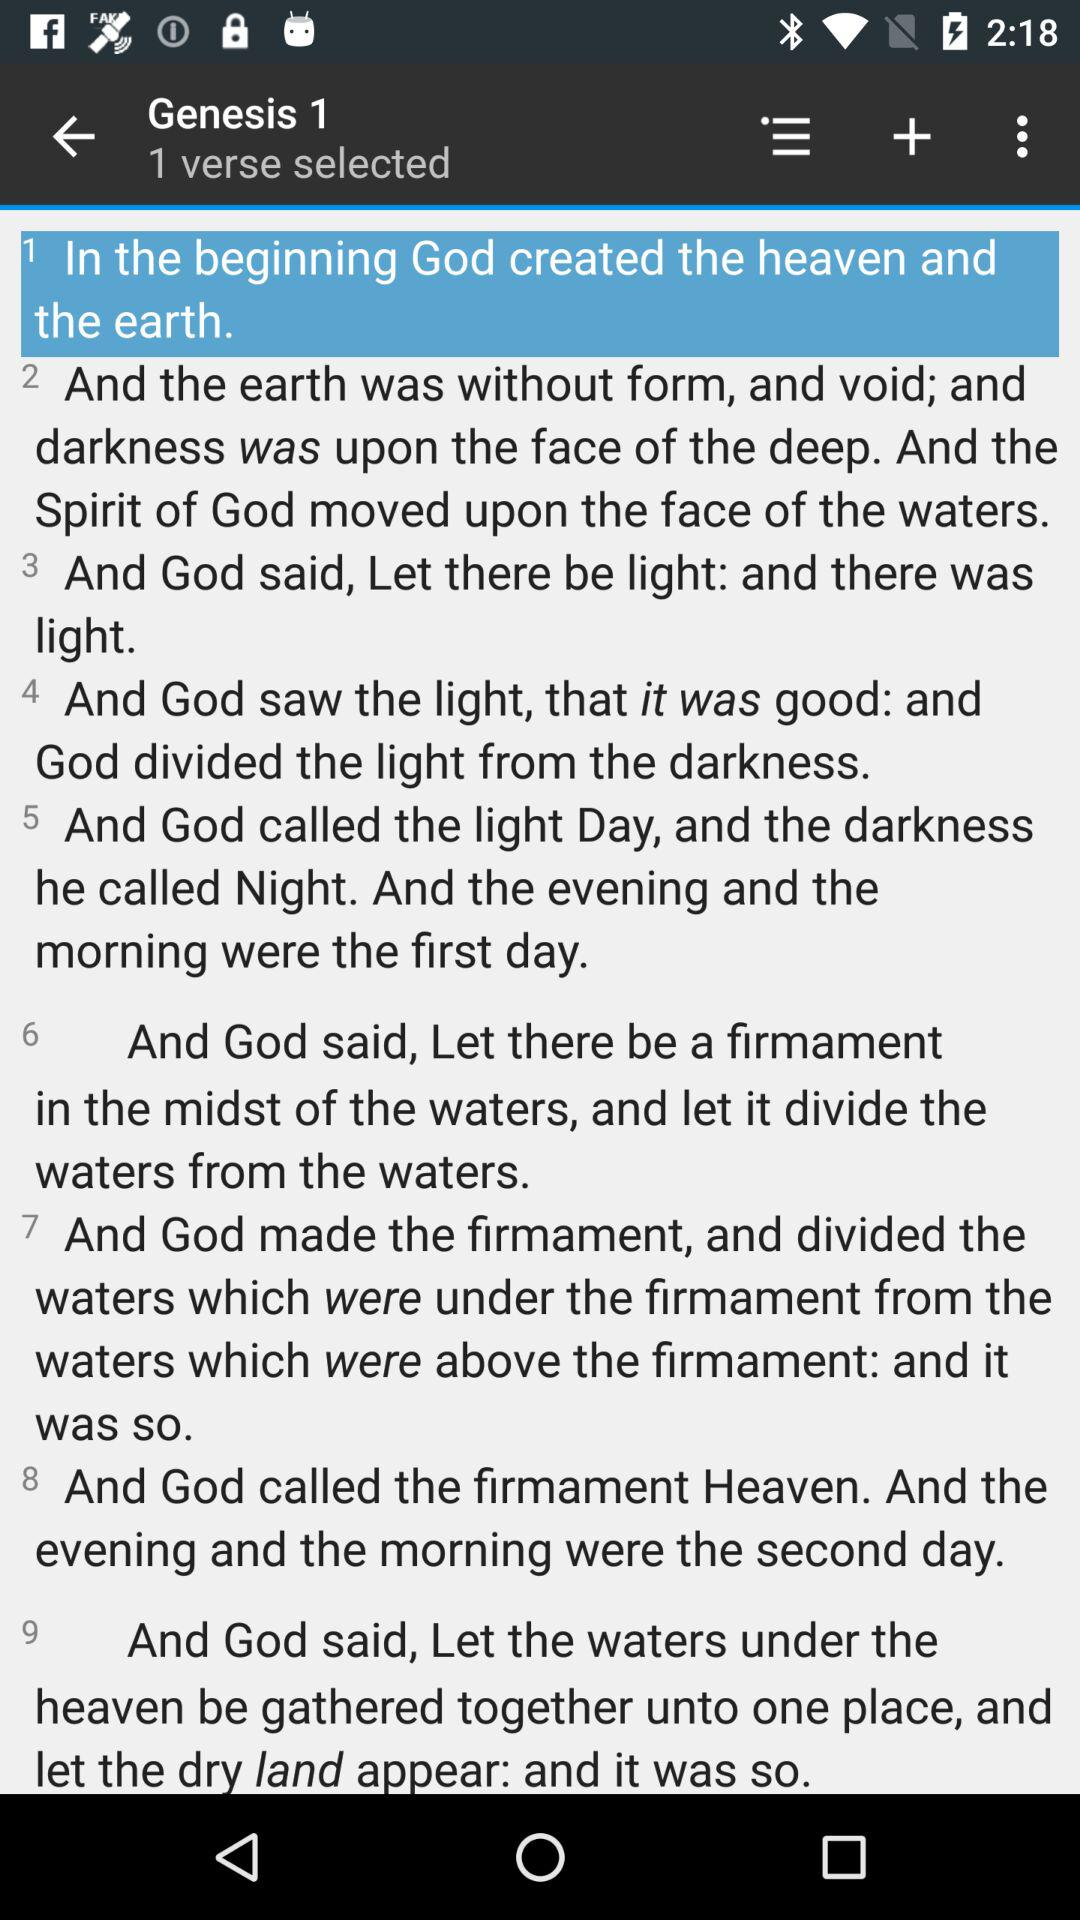What chapter of "Genesis" is displayed? The displayed chapter of "Genesis" is 1. 